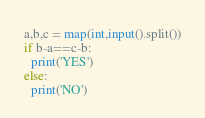<code> <loc_0><loc_0><loc_500><loc_500><_Python_>a,b,c = map(int,input().split())
if b-a==c-b:
  print('YES')
else:
  print('NO')</code> 